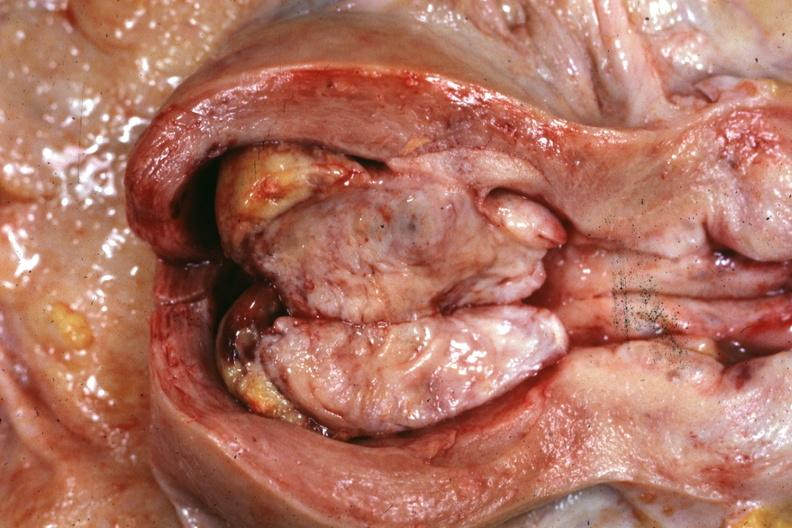what is present?
Answer the question using a single word or phrase. Female reproductive 